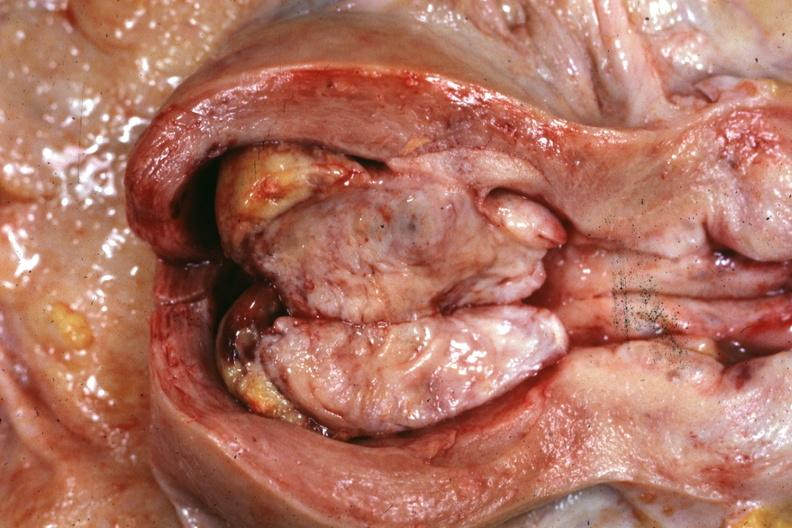what is present?
Answer the question using a single word or phrase. Female reproductive 